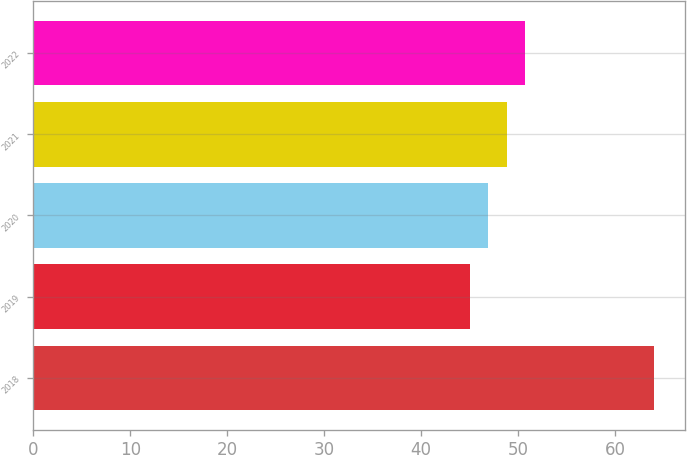<chart> <loc_0><loc_0><loc_500><loc_500><bar_chart><fcel>2018<fcel>2019<fcel>2020<fcel>2021<fcel>2022<nl><fcel>64<fcel>45<fcel>46.9<fcel>48.8<fcel>50.7<nl></chart> 